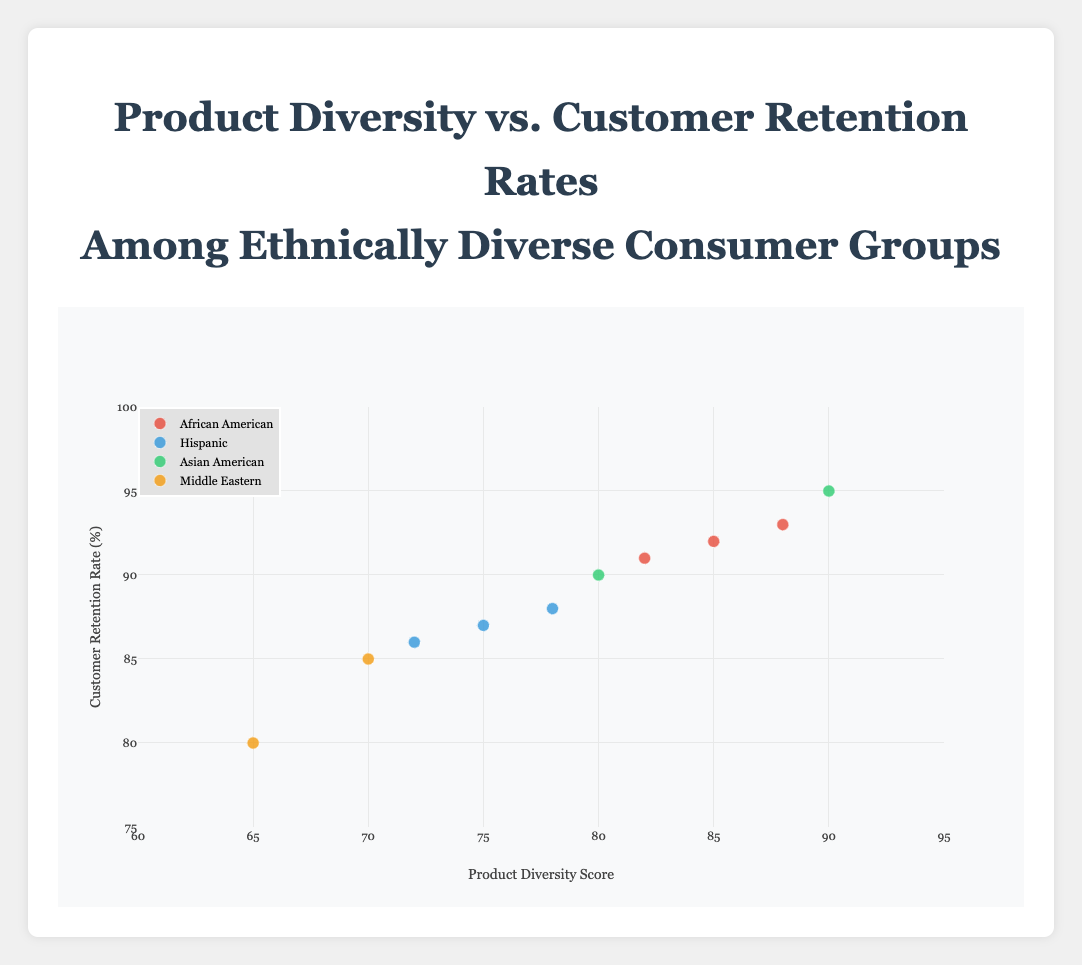what is the highest Customer Retention Rate seen in the figure? By looking at the y-axis of the scatter plot, identify the highest point corresponding to the Customer Retention Rate. The highest point is marked by Google.
Answer: 95 what is the title of the figure? The title is displayed clearly at the top center of the figure, indicating the focus of the data.
Answer: Product Diversity vs. Customer Retention Rates Among Ethnically Diverse Consumer Groups how many data points are there for the African American consumer group? Identify all points colored the same as the African American group and count them.
Answer: 3 which company has the lowest Product Diversity Score among Middle Eastern consumer groups? Check the x-axis values for the Middle Eastern points and identify the one with the lowest Product Diversity Score, which is Sony.
Answer: Sony compare the Customer Retention Rates between Apple and Samsung, which one is higher? Locate both points for Apple and Samsung based on the hover text and compare their y-axis values. Apple's retention rate of 90% is higher than Samsung’s 87%.
Answer: Apple what is the median Product Diversity Score of all companies? First, arrange the Product Diversity Scores (65, 70, 72, 75, 78, 80, 82, 85, 88, 90) in ascending order. The middle two values (midpoints) are 78 and 80. Their average is (78+80)/2 = 79.
Answer: 79 what trend do you observe between Product Diversity Score and Customer Retention Rates? Observing the general pattern in the shape/form of the data points, there’s a positive trend where higher Product Diversity Scores are generally associated with higher Customer Retention Rates.
Answer: Positive trend which ethnic consumer group has the widest range of Customer Retention Rates? Identify the highest and lowest Customer Retention Rates within each consumer group in the plot. African American ranges from 91 to 93, Hispanic ranges from 86 to 88, Asian American ranges from 90 to 95, Middle Eastern ranges from 80 to 85. Asian American has the widest range (90 to 95).
Answer: Asian American 